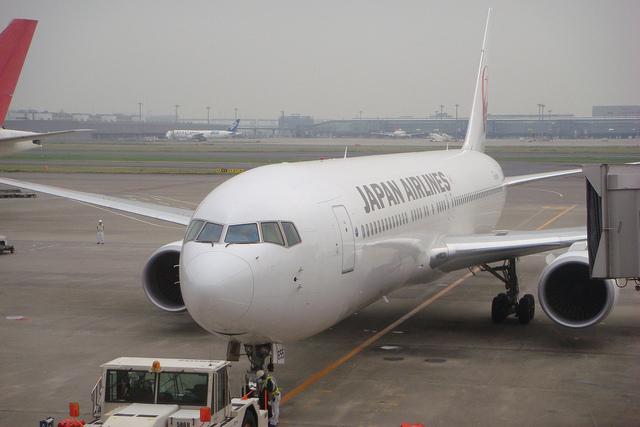Is this a virgin America airlines?
Write a very short answer. No. What kind of airlines in this?
Be succinct. Japan airlines. What are the weather conditions at the airport?
Keep it brief. Foggy. Where is this airplane from?
Write a very short answer. Japan. What is the name of the airline?
Keep it brief. Japan airlines. 